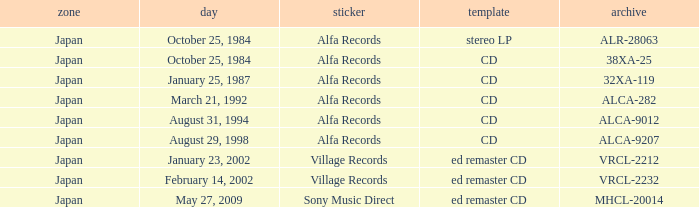What was the region of the release from May 27, 2009? Japan. 